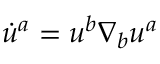Convert formula to latex. <formula><loc_0><loc_0><loc_500><loc_500>\dot { u } ^ { a } = u ^ { b } \nabla _ { b } u ^ { a }</formula> 